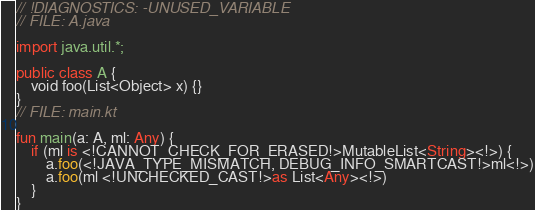<code> <loc_0><loc_0><loc_500><loc_500><_Kotlin_>// !DIAGNOSTICS: -UNUSED_VARIABLE
// FILE: A.java

import java.util.*;

public class A {
    void foo(List<Object> x) {}
}
// FILE: main.kt

fun main(a: A, ml: Any) {
    if (ml is <!CANNOT_CHECK_FOR_ERASED!>MutableList<String><!>) {
        a.foo(<!JAVA_TYPE_MISMATCH, DEBUG_INFO_SMARTCAST!>ml<!>)
        a.foo(ml <!UNCHECKED_CAST!>as List<Any><!>)
    }
}
</code> 